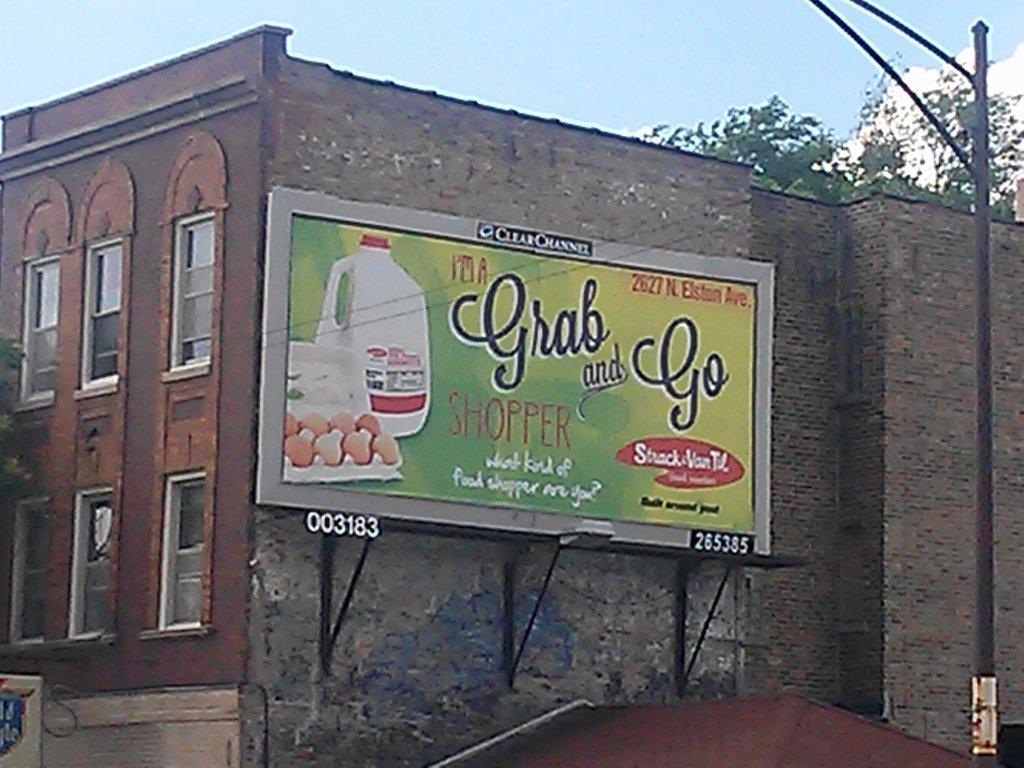<image>
Give a short and clear explanation of the subsequent image. A billboard saying I'm a grab and go shopper 